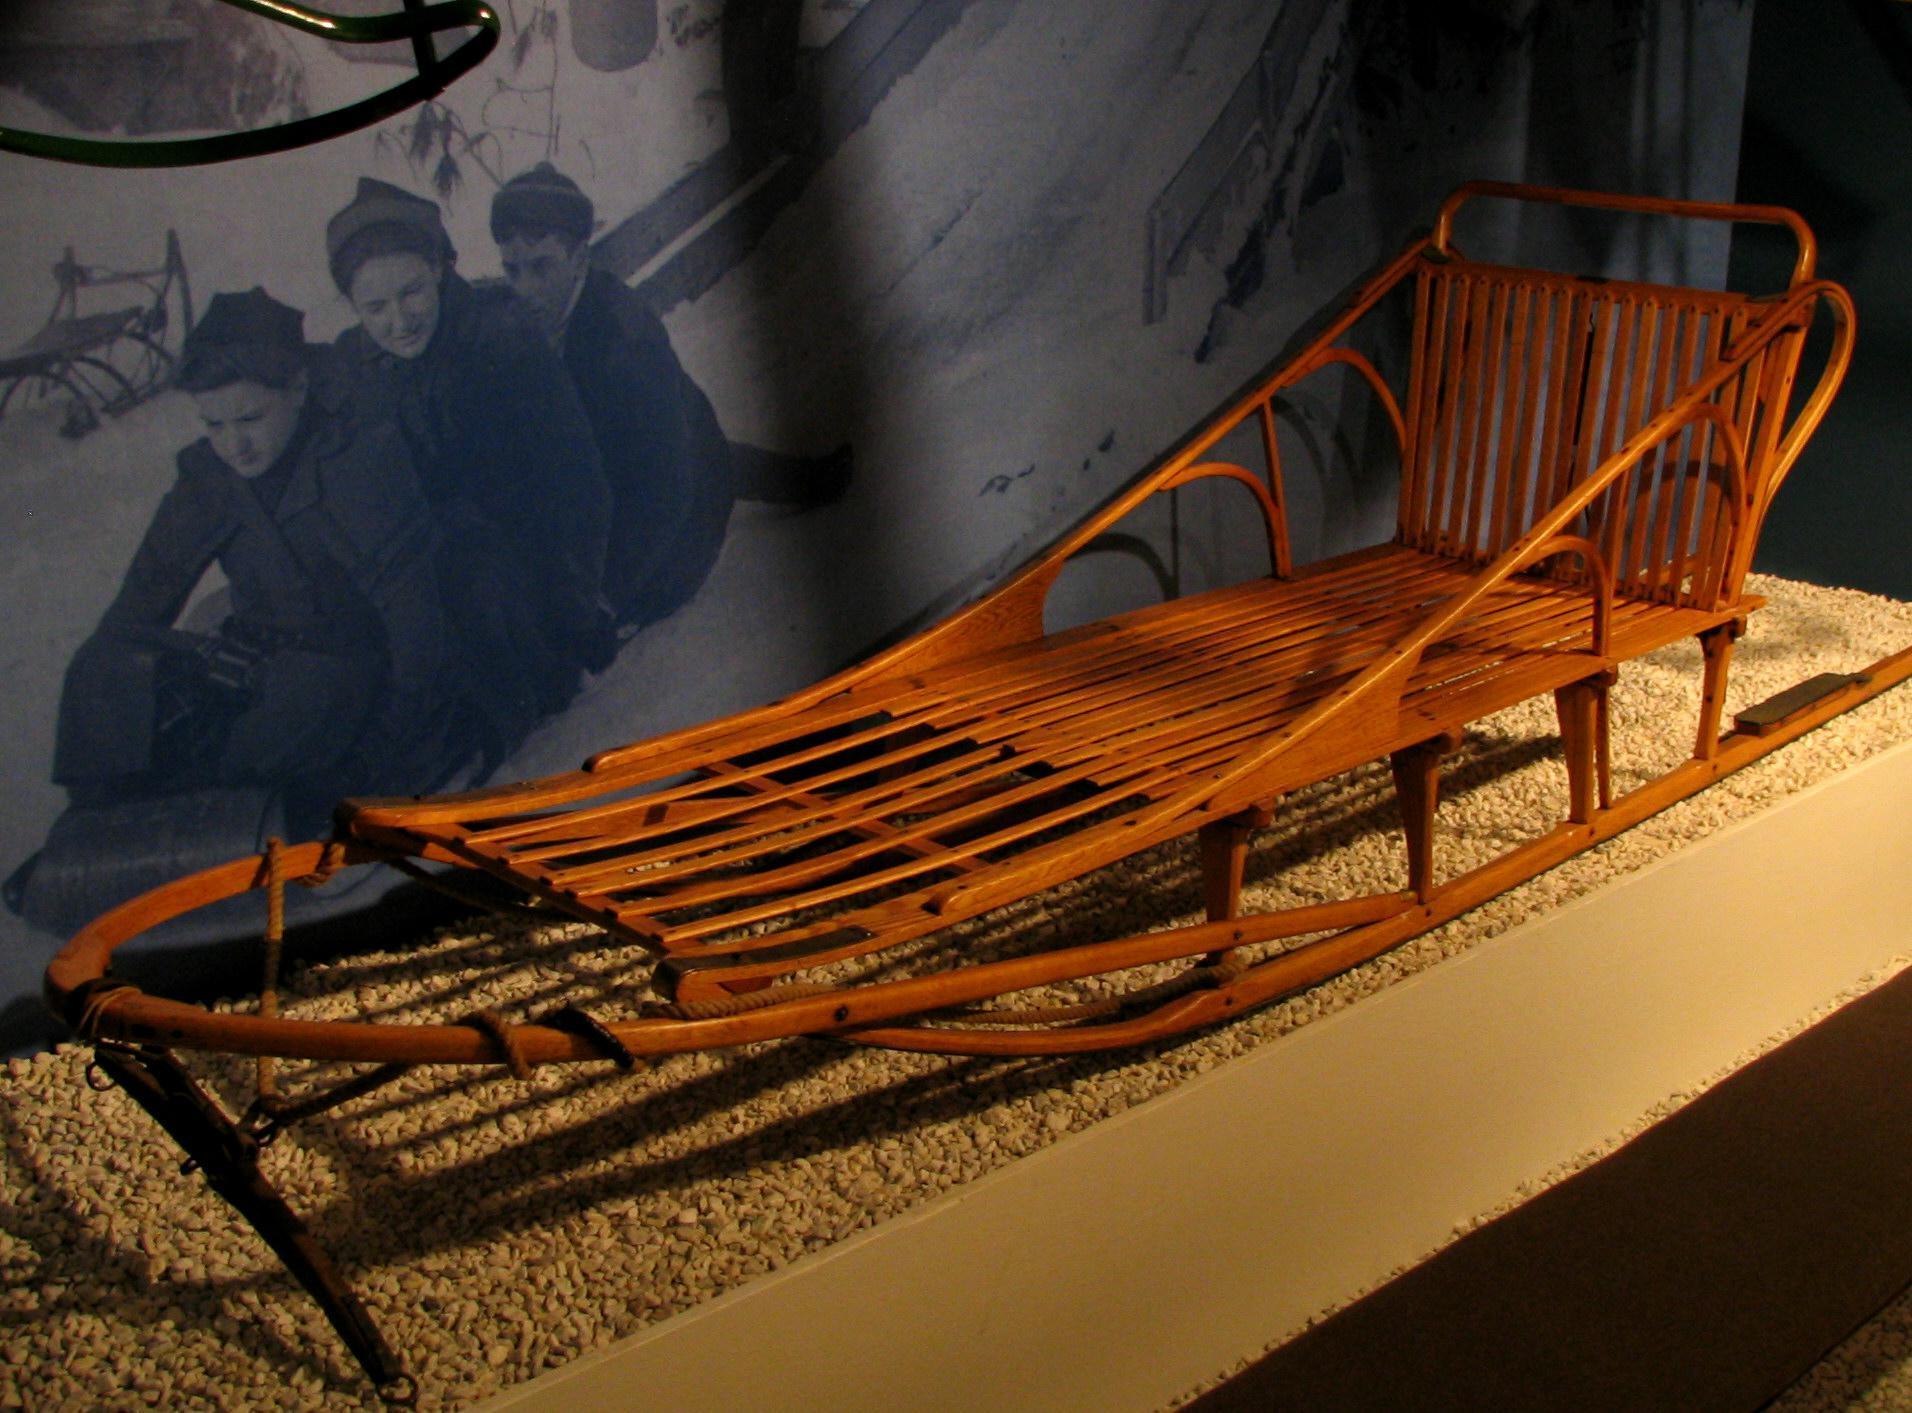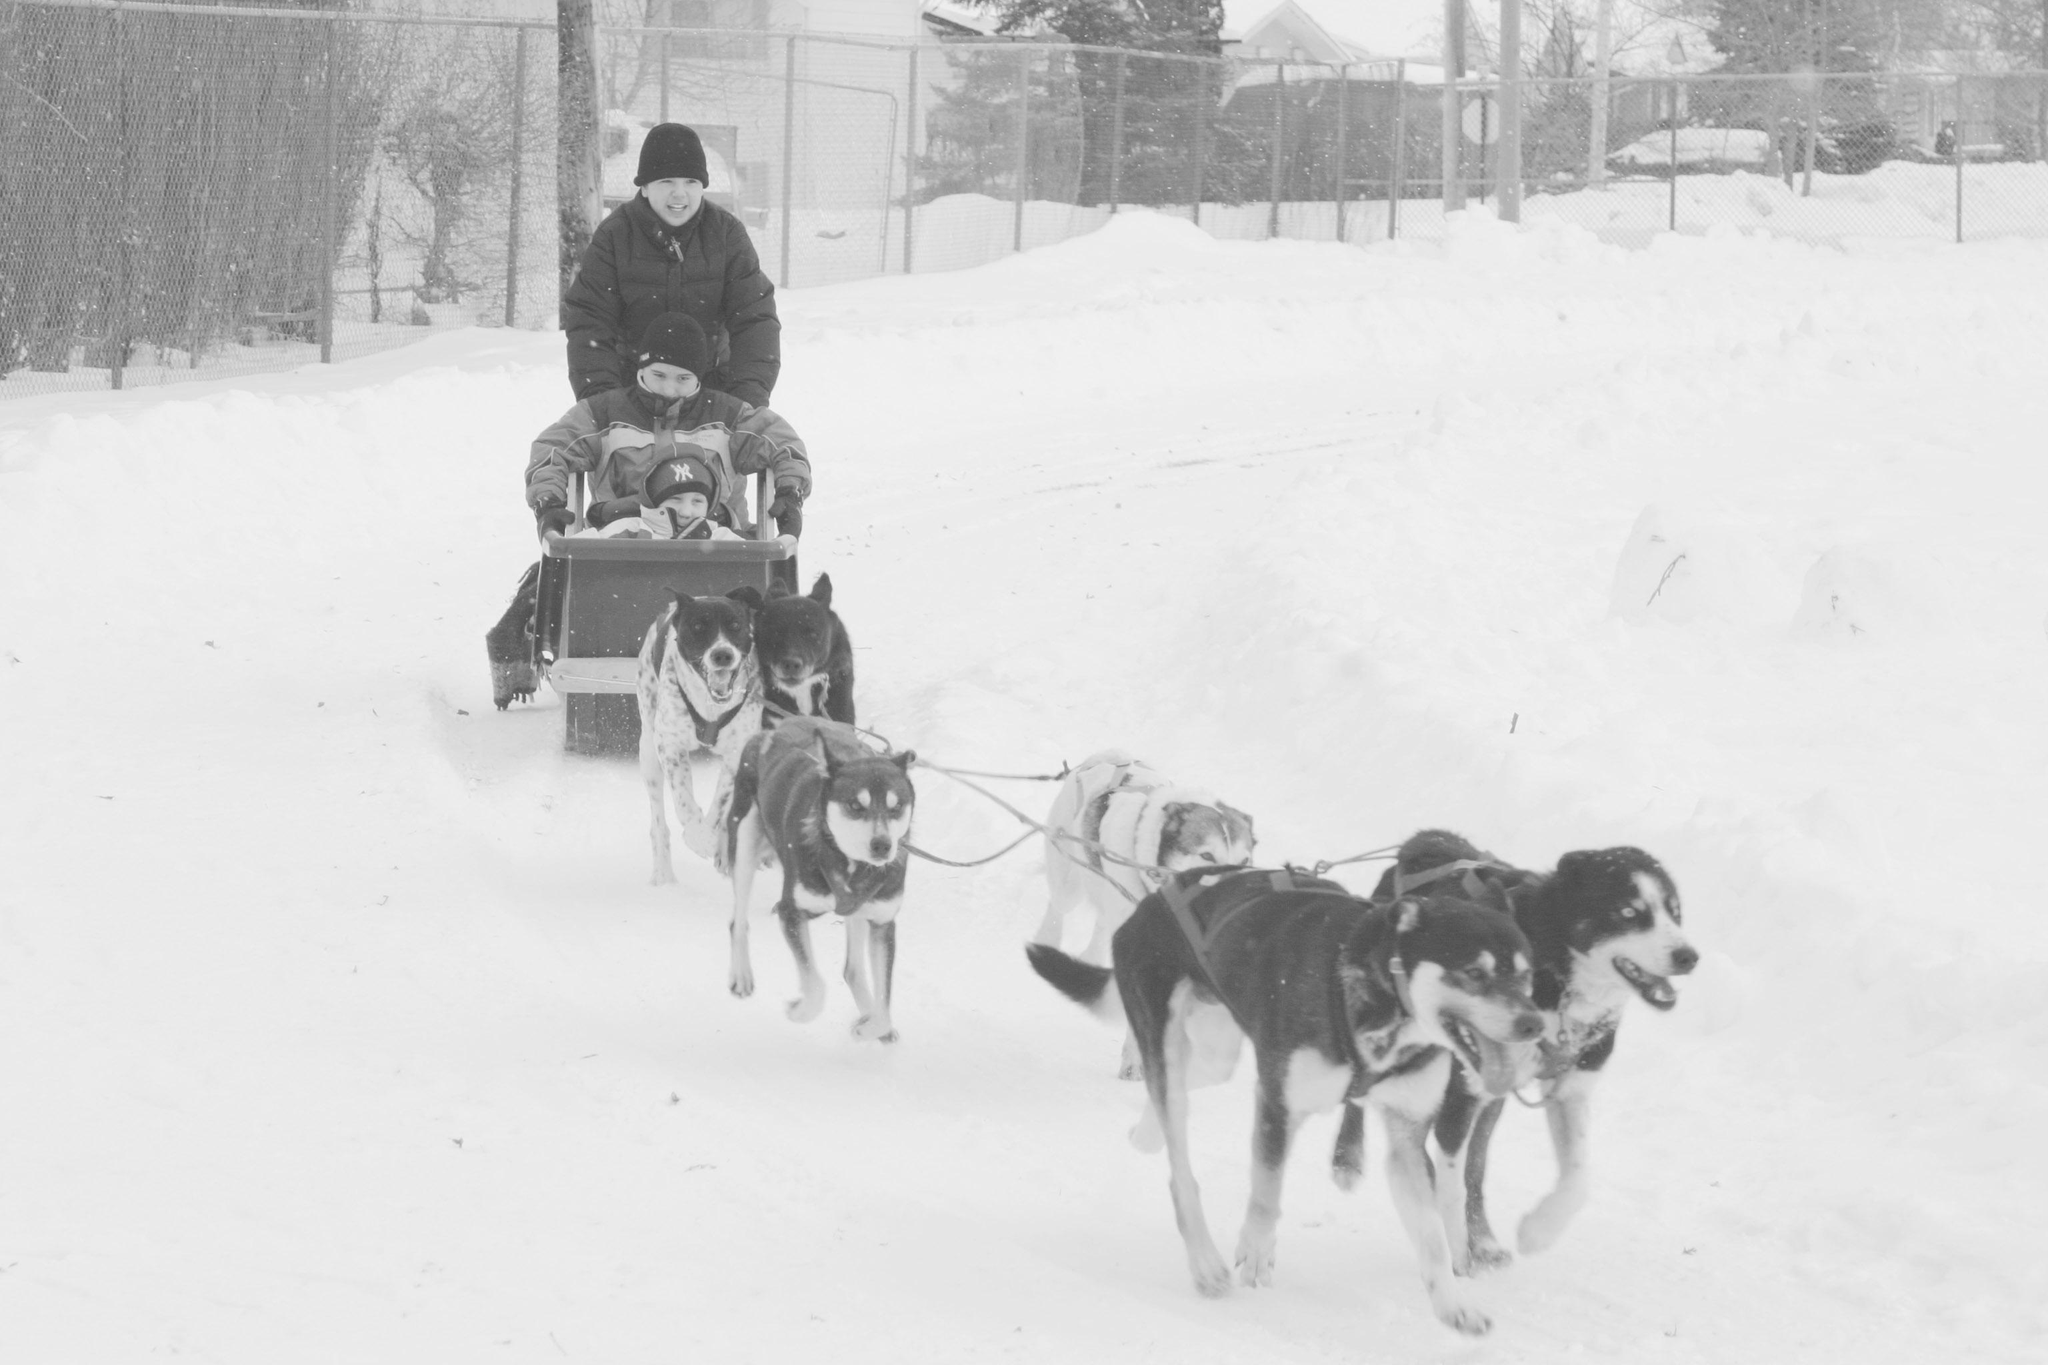The first image is the image on the left, the second image is the image on the right. Examine the images to the left and right. Is the description "The sled in the left image is facing right." accurate? Answer yes or no. No. 